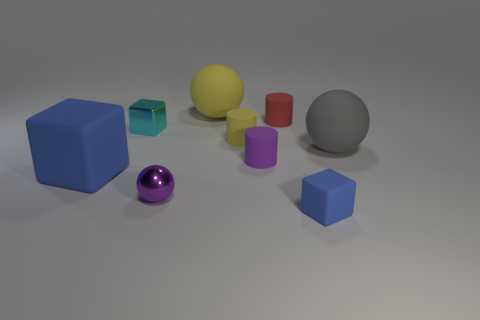Subtract 1 spheres. How many spheres are left? 2 Subtract all big matte spheres. How many spheres are left? 1 Add 1 matte things. How many objects exist? 10 Subtract all spheres. How many objects are left? 6 Add 7 purple metallic spheres. How many purple metallic spheres exist? 8 Subtract 1 red cylinders. How many objects are left? 8 Subtract all purple objects. Subtract all small balls. How many objects are left? 6 Add 6 small purple cylinders. How many small purple cylinders are left? 7 